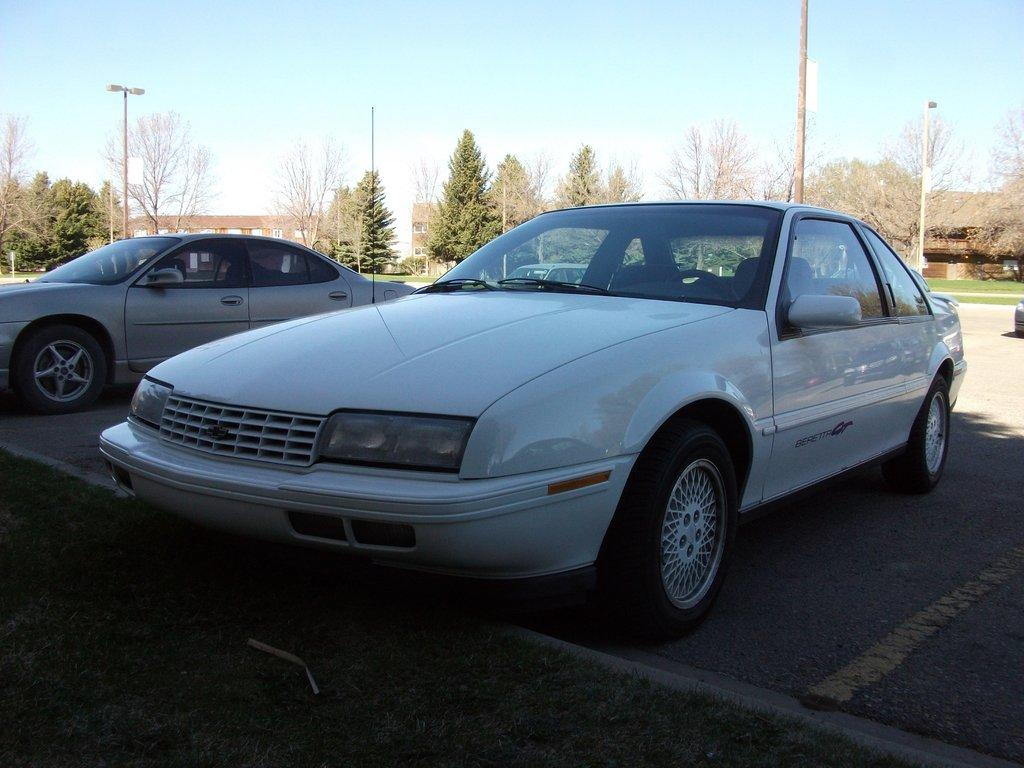What is happening in the center of the image? There are vehicles on the road in the center of the image. What can be seen in the background of the image? There are trees, houses, and poles in the background of the image. Is there a volcano erupting in the background of the image? No, there is no volcano present in the image. What type of art can be seen on the vehicles in the image? There is no information about any art on the vehicles in the image. 